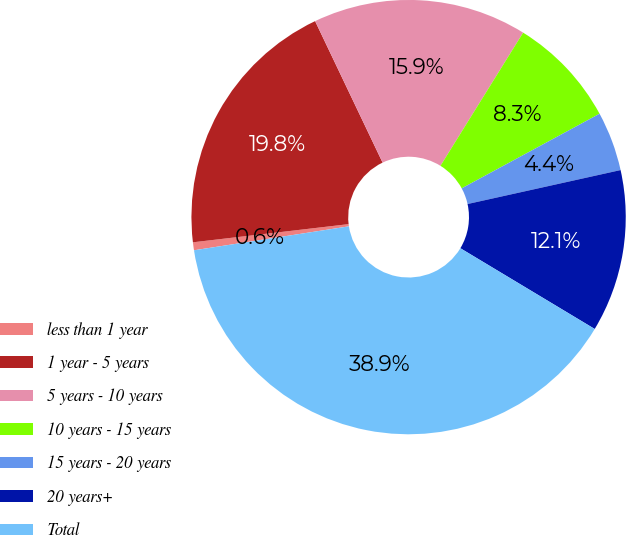Convert chart to OTSL. <chart><loc_0><loc_0><loc_500><loc_500><pie_chart><fcel>less than 1 year<fcel>1 year - 5 years<fcel>5 years - 10 years<fcel>10 years - 15 years<fcel>15 years - 20 years<fcel>20 years+<fcel>Total<nl><fcel>0.59%<fcel>19.77%<fcel>15.93%<fcel>8.26%<fcel>4.42%<fcel>12.09%<fcel>38.95%<nl></chart> 